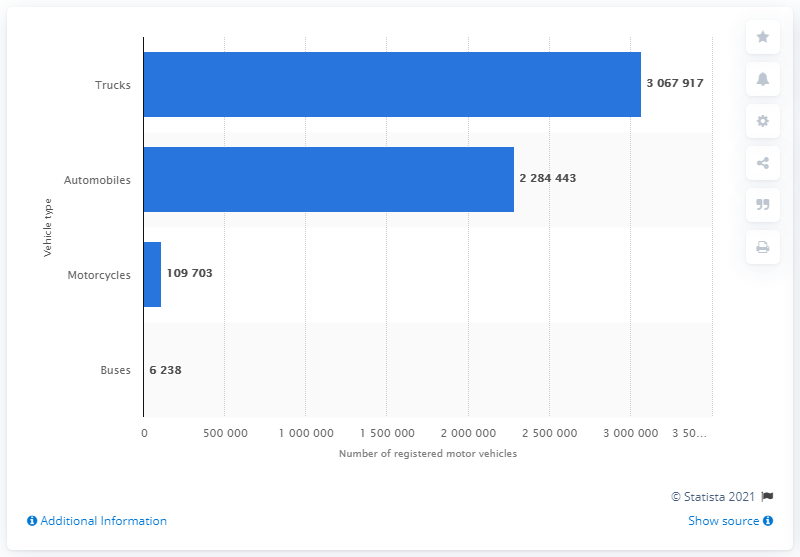Point out several critical features in this image. In 2016, a total of 228,443,456 automobiles were registered in the state of Alabama. 